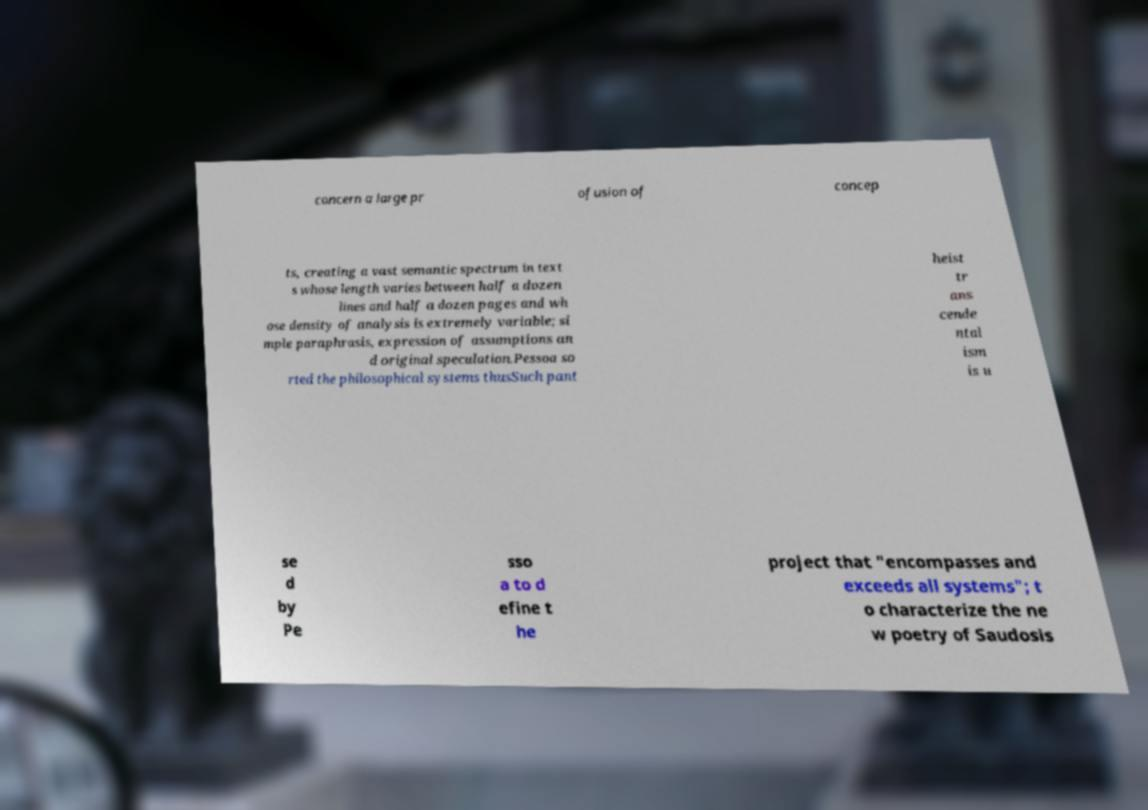I need the written content from this picture converted into text. Can you do that? concern a large pr ofusion of concep ts, creating a vast semantic spectrum in text s whose length varies between half a dozen lines and half a dozen pages and wh ose density of analysis is extremely variable; si mple paraphrasis, expression of assumptions an d original speculation.Pessoa so rted the philosophical systems thusSuch pant heist tr ans cende ntal ism is u se d by Pe sso a to d efine t he project that "encompasses and exceeds all systems"; t o characterize the ne w poetry of Saudosis 